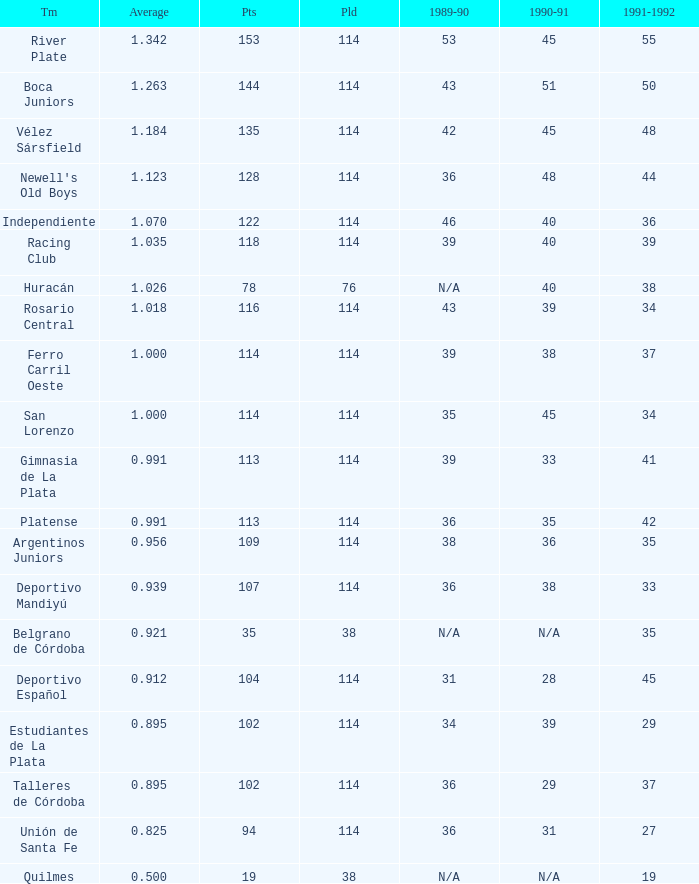Would you mind parsing the complete table? {'header': ['Tm', 'Average', 'Pts', 'Pld', '1989-90', '1990-91', '1991-1992'], 'rows': [['River Plate', '1.342', '153', '114', '53', '45', '55'], ['Boca Juniors', '1.263', '144', '114', '43', '51', '50'], ['Vélez Sársfield', '1.184', '135', '114', '42', '45', '48'], ["Newell's Old Boys", '1.123', '128', '114', '36', '48', '44'], ['Independiente', '1.070', '122', '114', '46', '40', '36'], ['Racing Club', '1.035', '118', '114', '39', '40', '39'], ['Huracán', '1.026', '78', '76', 'N/A', '40', '38'], ['Rosario Central', '1.018', '116', '114', '43', '39', '34'], ['Ferro Carril Oeste', '1.000', '114', '114', '39', '38', '37'], ['San Lorenzo', '1.000', '114', '114', '35', '45', '34'], ['Gimnasia de La Plata', '0.991', '113', '114', '39', '33', '41'], ['Platense', '0.991', '113', '114', '36', '35', '42'], ['Argentinos Juniors', '0.956', '109', '114', '38', '36', '35'], ['Deportivo Mandiyú', '0.939', '107', '114', '36', '38', '33'], ['Belgrano de Córdoba', '0.921', '35', '38', 'N/A', 'N/A', '35'], ['Deportivo Español', '0.912', '104', '114', '31', '28', '45'], ['Estudiantes de La Plata', '0.895', '102', '114', '34', '39', '29'], ['Talleres de Córdoba', '0.895', '102', '114', '36', '29', '37'], ['Unión de Santa Fe', '0.825', '94', '114', '36', '31', '27'], ['Quilmes', '0.500', '19', '38', 'N/A', 'N/A', '19']]} How much 1991-1992 has a Team of gimnasia de la plata, and more than 113 points? 0.0. 